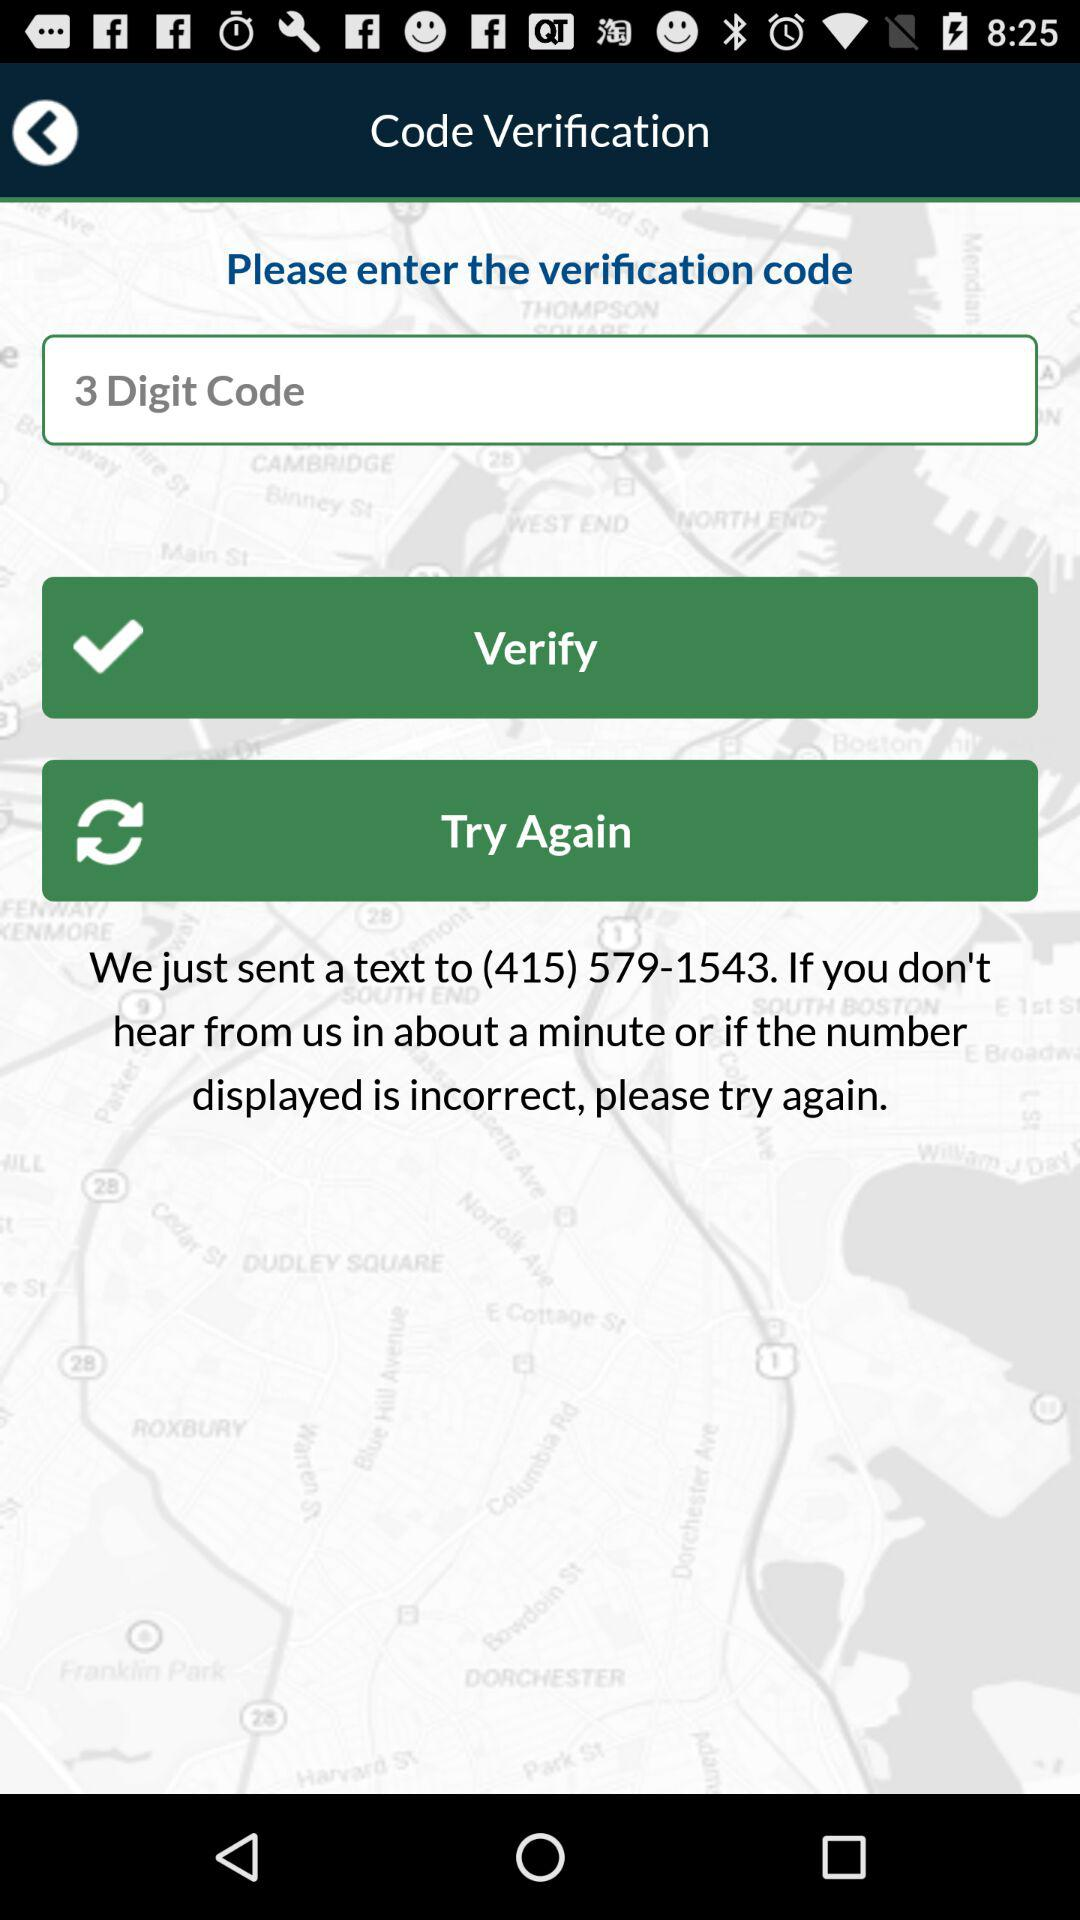On what number 3 digit code is sent? The 3 digit code is sent to (415) 579-1543. 